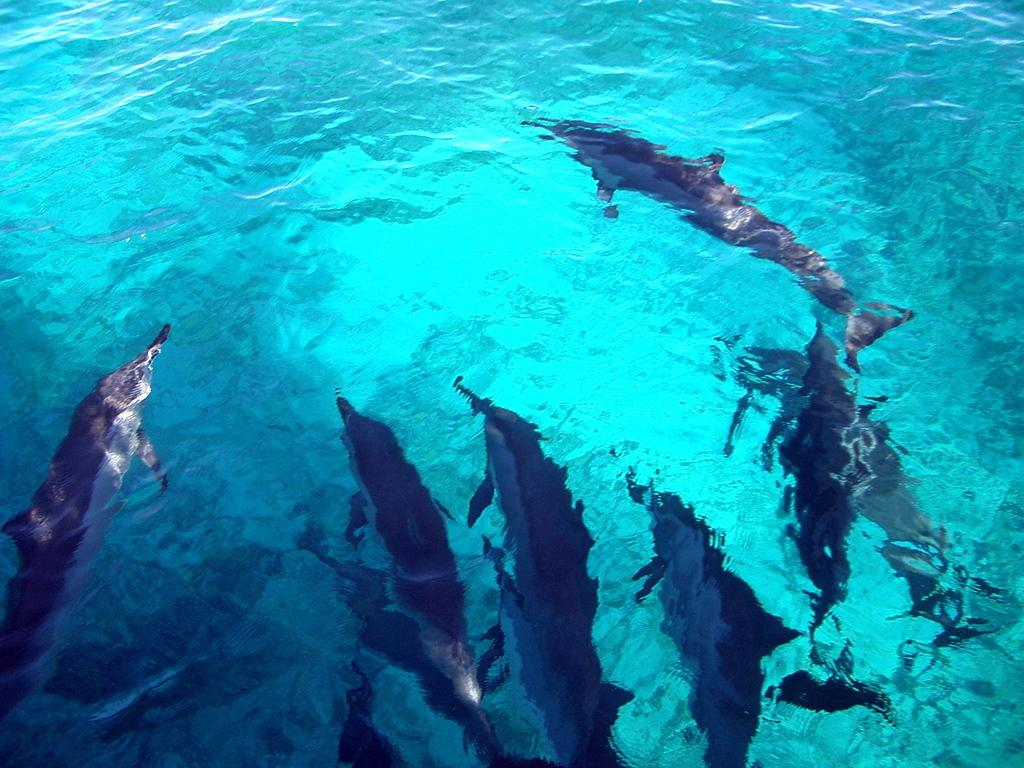What type of animals can be seen in the image? There are fishes in the image. What color is the water in the image? The water in the image is green in color. What type of hair can be seen on the fishes in the image? There is no hair present on the fishes in the image, as they are aquatic animals without hair. 